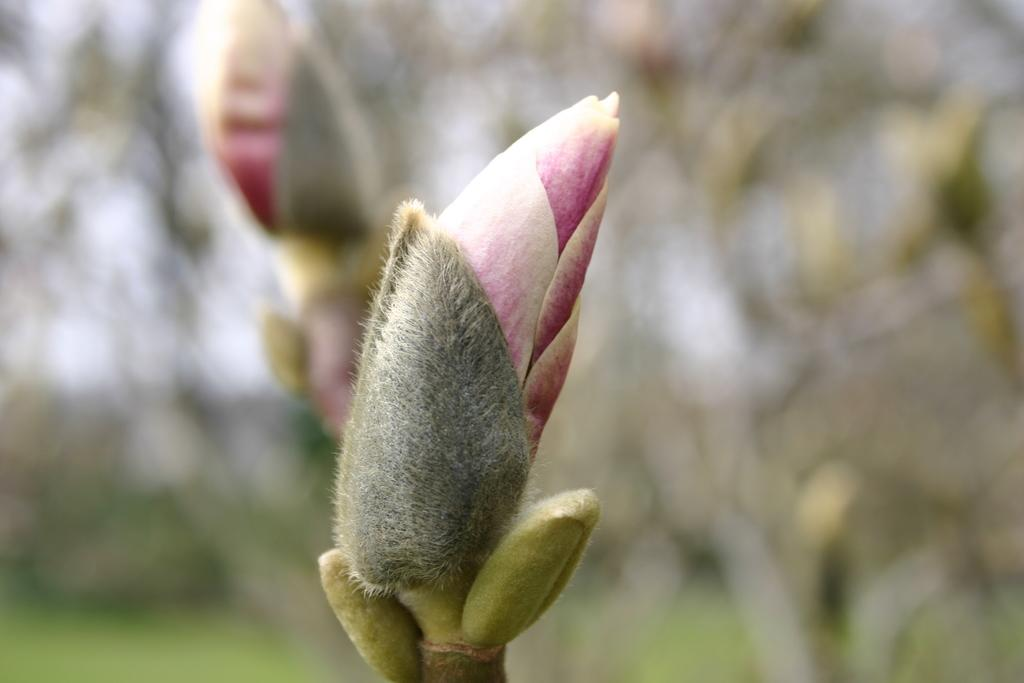What is the main subject of the image? There is a flower in the image. Can you describe the background of the image? The background of the image is blurry. What type of queen is sitting on the giraffe in the image? There is no queen or giraffe present in the image; it features a flower with a blurry background. What substance is being used to create the flower in the image? The image is a photograph or illustration, and no substance is being used to create the flower in the image. 